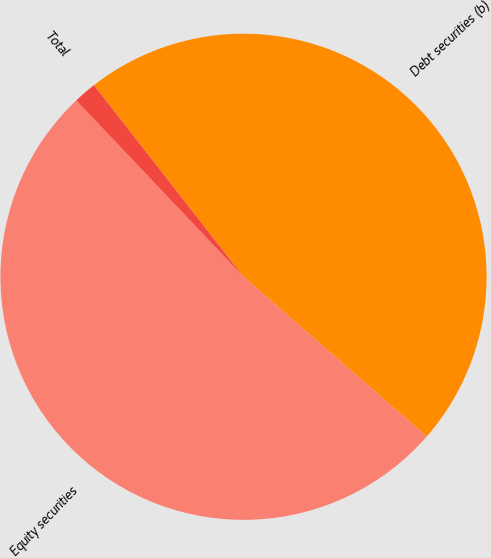<chart> <loc_0><loc_0><loc_500><loc_500><pie_chart><fcel>Debt securities (b)<fcel>Equity securities<fcel>Total<nl><fcel>46.96%<fcel>51.51%<fcel>1.53%<nl></chart> 